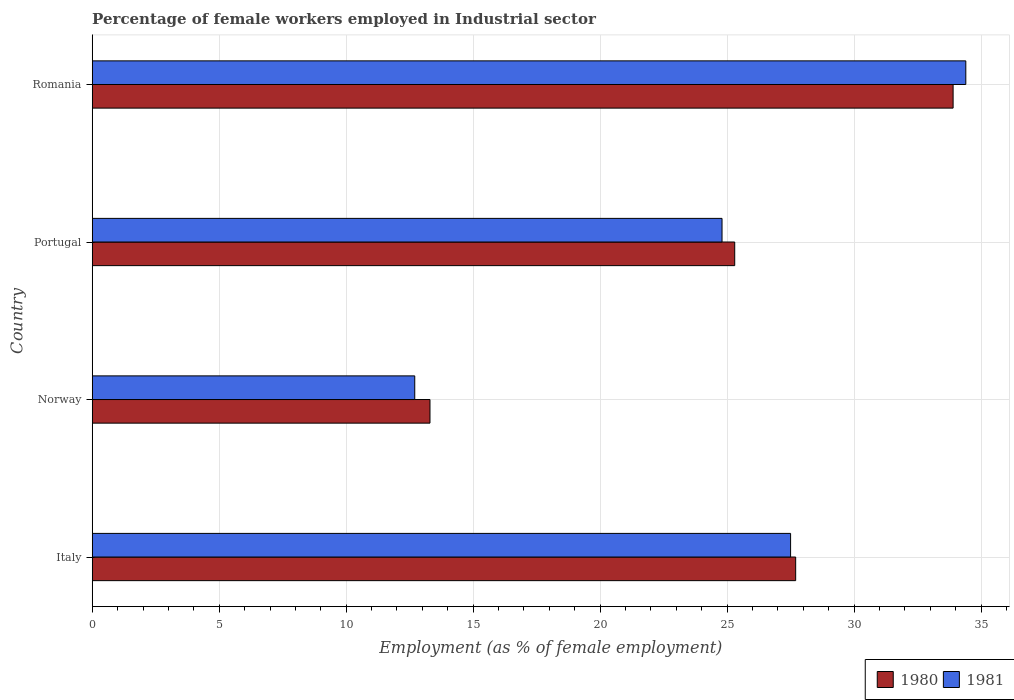How many groups of bars are there?
Make the answer very short. 4. Are the number of bars per tick equal to the number of legend labels?
Give a very brief answer. Yes. Are the number of bars on each tick of the Y-axis equal?
Give a very brief answer. Yes. How many bars are there on the 3rd tick from the bottom?
Your answer should be compact. 2. What is the label of the 4th group of bars from the top?
Ensure brevity in your answer.  Italy. What is the percentage of females employed in Industrial sector in 1981 in Romania?
Make the answer very short. 34.4. Across all countries, what is the maximum percentage of females employed in Industrial sector in 1981?
Give a very brief answer. 34.4. Across all countries, what is the minimum percentage of females employed in Industrial sector in 1980?
Keep it short and to the point. 13.3. In which country was the percentage of females employed in Industrial sector in 1981 maximum?
Your response must be concise. Romania. What is the total percentage of females employed in Industrial sector in 1981 in the graph?
Provide a succinct answer. 99.4. What is the difference between the percentage of females employed in Industrial sector in 1980 in Italy and that in Romania?
Your answer should be very brief. -6.2. What is the difference between the percentage of females employed in Industrial sector in 1981 in Portugal and the percentage of females employed in Industrial sector in 1980 in Norway?
Ensure brevity in your answer.  11.5. What is the average percentage of females employed in Industrial sector in 1981 per country?
Provide a succinct answer. 24.85. What is the difference between the percentage of females employed in Industrial sector in 1981 and percentage of females employed in Industrial sector in 1980 in Italy?
Give a very brief answer. -0.2. What is the ratio of the percentage of females employed in Industrial sector in 1981 in Norway to that in Portugal?
Ensure brevity in your answer.  0.51. Is the percentage of females employed in Industrial sector in 1981 in Portugal less than that in Romania?
Your response must be concise. Yes. Is the difference between the percentage of females employed in Industrial sector in 1981 in Italy and Portugal greater than the difference between the percentage of females employed in Industrial sector in 1980 in Italy and Portugal?
Provide a succinct answer. Yes. What is the difference between the highest and the second highest percentage of females employed in Industrial sector in 1981?
Provide a succinct answer. 6.9. What is the difference between the highest and the lowest percentage of females employed in Industrial sector in 1981?
Make the answer very short. 21.7. Is the sum of the percentage of females employed in Industrial sector in 1981 in Norway and Portugal greater than the maximum percentage of females employed in Industrial sector in 1980 across all countries?
Ensure brevity in your answer.  Yes. What does the 1st bar from the top in Romania represents?
Your answer should be very brief. 1981. How many countries are there in the graph?
Your answer should be very brief. 4. What is the difference between two consecutive major ticks on the X-axis?
Keep it short and to the point. 5. Are the values on the major ticks of X-axis written in scientific E-notation?
Offer a terse response. No. Does the graph contain any zero values?
Your response must be concise. No. Where does the legend appear in the graph?
Offer a terse response. Bottom right. How are the legend labels stacked?
Provide a short and direct response. Horizontal. What is the title of the graph?
Give a very brief answer. Percentage of female workers employed in Industrial sector. What is the label or title of the X-axis?
Provide a succinct answer. Employment (as % of female employment). What is the label or title of the Y-axis?
Provide a succinct answer. Country. What is the Employment (as % of female employment) in 1980 in Italy?
Your answer should be very brief. 27.7. What is the Employment (as % of female employment) in 1980 in Norway?
Make the answer very short. 13.3. What is the Employment (as % of female employment) of 1981 in Norway?
Keep it short and to the point. 12.7. What is the Employment (as % of female employment) in 1980 in Portugal?
Keep it short and to the point. 25.3. What is the Employment (as % of female employment) in 1981 in Portugal?
Your answer should be very brief. 24.8. What is the Employment (as % of female employment) of 1980 in Romania?
Your answer should be very brief. 33.9. What is the Employment (as % of female employment) of 1981 in Romania?
Your answer should be very brief. 34.4. Across all countries, what is the maximum Employment (as % of female employment) in 1980?
Your response must be concise. 33.9. Across all countries, what is the maximum Employment (as % of female employment) in 1981?
Keep it short and to the point. 34.4. Across all countries, what is the minimum Employment (as % of female employment) of 1980?
Your response must be concise. 13.3. Across all countries, what is the minimum Employment (as % of female employment) in 1981?
Provide a short and direct response. 12.7. What is the total Employment (as % of female employment) of 1980 in the graph?
Offer a very short reply. 100.2. What is the total Employment (as % of female employment) in 1981 in the graph?
Your answer should be very brief. 99.4. What is the difference between the Employment (as % of female employment) in 1980 in Italy and that in Norway?
Offer a terse response. 14.4. What is the difference between the Employment (as % of female employment) in 1980 in Italy and that in Portugal?
Offer a terse response. 2.4. What is the difference between the Employment (as % of female employment) of 1981 in Italy and that in Portugal?
Offer a very short reply. 2.7. What is the difference between the Employment (as % of female employment) of 1980 in Italy and that in Romania?
Offer a very short reply. -6.2. What is the difference between the Employment (as % of female employment) in 1980 in Norway and that in Portugal?
Offer a terse response. -12. What is the difference between the Employment (as % of female employment) of 1981 in Norway and that in Portugal?
Provide a succinct answer. -12.1. What is the difference between the Employment (as % of female employment) in 1980 in Norway and that in Romania?
Your answer should be very brief. -20.6. What is the difference between the Employment (as % of female employment) of 1981 in Norway and that in Romania?
Provide a succinct answer. -21.7. What is the difference between the Employment (as % of female employment) in 1981 in Portugal and that in Romania?
Ensure brevity in your answer.  -9.6. What is the difference between the Employment (as % of female employment) of 1980 in Italy and the Employment (as % of female employment) of 1981 in Norway?
Your answer should be very brief. 15. What is the difference between the Employment (as % of female employment) in 1980 in Italy and the Employment (as % of female employment) in 1981 in Romania?
Give a very brief answer. -6.7. What is the difference between the Employment (as % of female employment) of 1980 in Norway and the Employment (as % of female employment) of 1981 in Portugal?
Offer a terse response. -11.5. What is the difference between the Employment (as % of female employment) of 1980 in Norway and the Employment (as % of female employment) of 1981 in Romania?
Provide a short and direct response. -21.1. What is the average Employment (as % of female employment) in 1980 per country?
Ensure brevity in your answer.  25.05. What is the average Employment (as % of female employment) in 1981 per country?
Offer a very short reply. 24.85. What is the difference between the Employment (as % of female employment) of 1980 and Employment (as % of female employment) of 1981 in Italy?
Your response must be concise. 0.2. What is the difference between the Employment (as % of female employment) in 1980 and Employment (as % of female employment) in 1981 in Norway?
Your answer should be compact. 0.6. What is the difference between the Employment (as % of female employment) of 1980 and Employment (as % of female employment) of 1981 in Portugal?
Keep it short and to the point. 0.5. What is the difference between the Employment (as % of female employment) in 1980 and Employment (as % of female employment) in 1981 in Romania?
Offer a very short reply. -0.5. What is the ratio of the Employment (as % of female employment) of 1980 in Italy to that in Norway?
Provide a succinct answer. 2.08. What is the ratio of the Employment (as % of female employment) in 1981 in Italy to that in Norway?
Your response must be concise. 2.17. What is the ratio of the Employment (as % of female employment) of 1980 in Italy to that in Portugal?
Offer a very short reply. 1.09. What is the ratio of the Employment (as % of female employment) in 1981 in Italy to that in Portugal?
Give a very brief answer. 1.11. What is the ratio of the Employment (as % of female employment) of 1980 in Italy to that in Romania?
Make the answer very short. 0.82. What is the ratio of the Employment (as % of female employment) in 1981 in Italy to that in Romania?
Keep it short and to the point. 0.8. What is the ratio of the Employment (as % of female employment) in 1980 in Norway to that in Portugal?
Make the answer very short. 0.53. What is the ratio of the Employment (as % of female employment) of 1981 in Norway to that in Portugal?
Keep it short and to the point. 0.51. What is the ratio of the Employment (as % of female employment) of 1980 in Norway to that in Romania?
Offer a terse response. 0.39. What is the ratio of the Employment (as % of female employment) in 1981 in Norway to that in Romania?
Make the answer very short. 0.37. What is the ratio of the Employment (as % of female employment) of 1980 in Portugal to that in Romania?
Your answer should be very brief. 0.75. What is the ratio of the Employment (as % of female employment) in 1981 in Portugal to that in Romania?
Provide a short and direct response. 0.72. What is the difference between the highest and the second highest Employment (as % of female employment) of 1980?
Your response must be concise. 6.2. What is the difference between the highest and the lowest Employment (as % of female employment) of 1980?
Keep it short and to the point. 20.6. What is the difference between the highest and the lowest Employment (as % of female employment) of 1981?
Make the answer very short. 21.7. 